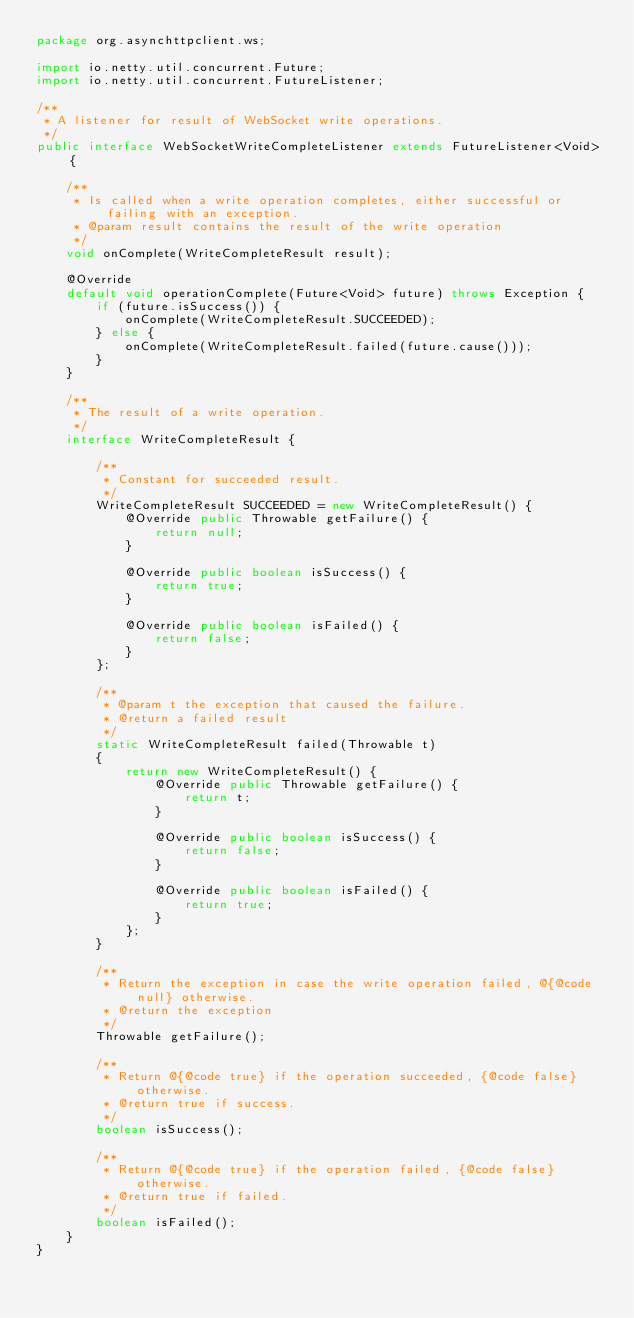Convert code to text. <code><loc_0><loc_0><loc_500><loc_500><_Java_>package org.asynchttpclient.ws;

import io.netty.util.concurrent.Future;
import io.netty.util.concurrent.FutureListener;

/**
 * A listener for result of WebSocket write operations.
 */
public interface WebSocketWriteCompleteListener extends FutureListener<Void> {

    /**
     * Is called when a write operation completes, either successful or failing with an exception.
     * @param result contains the result of the write operation
     */
    void onComplete(WriteCompleteResult result);

    @Override
    default void operationComplete(Future<Void> future) throws Exception {
        if (future.isSuccess()) {
            onComplete(WriteCompleteResult.SUCCEEDED);
        } else {
            onComplete(WriteCompleteResult.failed(future.cause()));
        }
    }

    /**
     * The result of a write operation.
     */
    interface WriteCompleteResult {

        /**
         * Constant for succeeded result.
         */
        WriteCompleteResult SUCCEEDED = new WriteCompleteResult() {
            @Override public Throwable getFailure() {
                return null;
            }

            @Override public boolean isSuccess() {
                return true;
            }

            @Override public boolean isFailed() {
                return false;
            }
        };

        /**
         * @param t the exception that caused the failure.
         * @return a failed result
         */
        static WriteCompleteResult failed(Throwable t)
        {
            return new WriteCompleteResult() {
                @Override public Throwable getFailure() {
                    return t;
                }

                @Override public boolean isSuccess() {
                    return false;
                }

                @Override public boolean isFailed() {
                    return true;
                }
            };
        }

        /**
         * Return the exception in case the write operation failed, @{@code null} otherwise.
         * @return the exception
         */
        Throwable getFailure();

        /**
         * Return @{@code true} if the operation succeeded, {@code false} otherwise.
         * @return true if success.
         */
        boolean isSuccess();

        /**
         * Return @{@code true} if the operation failed, {@code false} otherwise.
         * @return true if failed.
         */
        boolean isFailed();
    }
}
</code> 